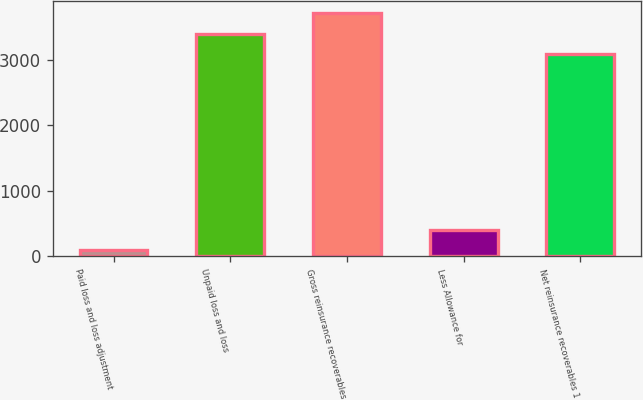Convert chart. <chart><loc_0><loc_0><loc_500><loc_500><bar_chart><fcel>Paid loss and loss adjustment<fcel>Unpaid loss and loss<fcel>Gross reinsurance recoverables<fcel>Less Allowance for<fcel>Net reinsurance recoverables 1<nl><fcel>89<fcel>3401.1<fcel>3717.2<fcel>405.1<fcel>3085<nl></chart> 